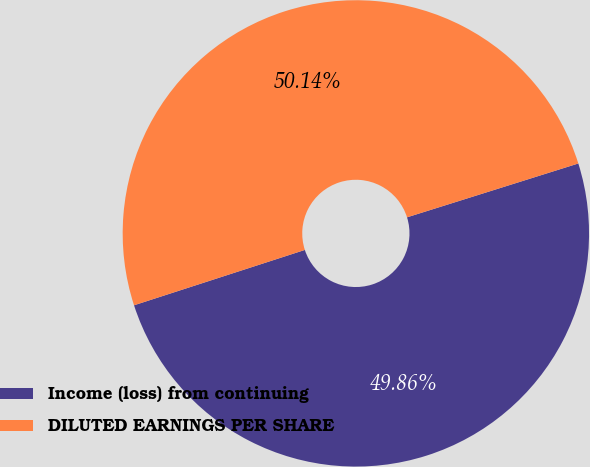Convert chart to OTSL. <chart><loc_0><loc_0><loc_500><loc_500><pie_chart><fcel>Income (loss) from continuing<fcel>DILUTED EARNINGS PER SHARE<nl><fcel>49.86%<fcel>50.14%<nl></chart> 